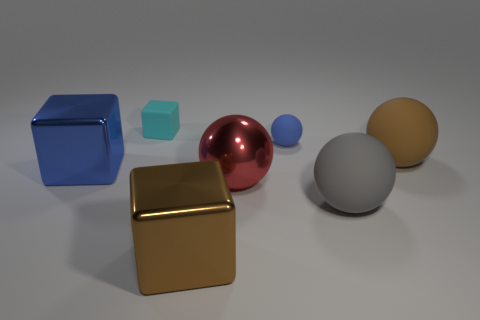The cube that is behind the big red metal object and in front of the blue matte sphere is made of what material?
Offer a very short reply. Metal. There is a brown thing in front of the brown thing that is to the right of the tiny blue object; is there a tiny blue ball that is to the right of it?
Keep it short and to the point. Yes. What is the shape of the brown thing that is made of the same material as the large red sphere?
Your answer should be very brief. Cube. Are there fewer gray balls in front of the brown matte object than large brown spheres to the left of the small blue rubber ball?
Ensure brevity in your answer.  No. What number of tiny objects are shiny cubes or brown cubes?
Ensure brevity in your answer.  0. Do the big rubber thing that is in front of the brown sphere and the large metal object on the left side of the cyan block have the same shape?
Offer a very short reply. No. There is a blue object that is in front of the brown thing behind the shiny block left of the tiny cyan rubber block; how big is it?
Provide a succinct answer. Large. There is a metal object in front of the gray sphere; what is its size?
Ensure brevity in your answer.  Large. What is the material of the blue object that is on the right side of the tiny cyan rubber thing?
Keep it short and to the point. Rubber. How many cyan things are either small cubes or tiny spheres?
Ensure brevity in your answer.  1. 